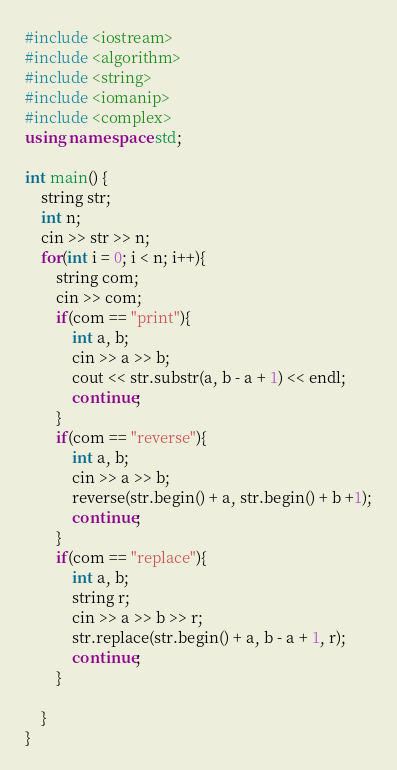Convert code to text. <code><loc_0><loc_0><loc_500><loc_500><_C++_>#include <iostream>
#include <algorithm>
#include <string>
#include <iomanip>
#include <complex>
using namespace std;

int main() {
    string str;
    int n;
    cin >> str >> n;
    for(int i = 0; i < n; i++){
        string com;
        cin >> com;
        if(com == "print"){
            int a, b;
            cin >> a >> b;
            cout << str.substr(a, b - a + 1) << endl;
            continue;
        }
        if(com == "reverse"){
            int a, b;
            cin >> a >> b;
            reverse(str.begin() + a, str.begin() + b +1);
            continue;
        }
        if(com == "replace"){
            int a, b;
            string r;
            cin >> a >> b >> r;
            str.replace(str.begin() + a, b - a + 1, r);
            continue;
        }

    }
}
</code> 